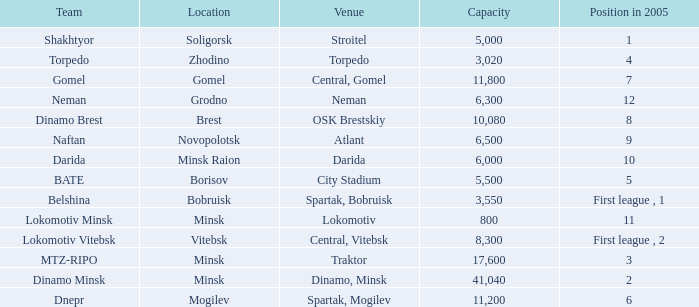Can you tell me the Capacity that has the Position in 2005 of 8? 10080.0. 